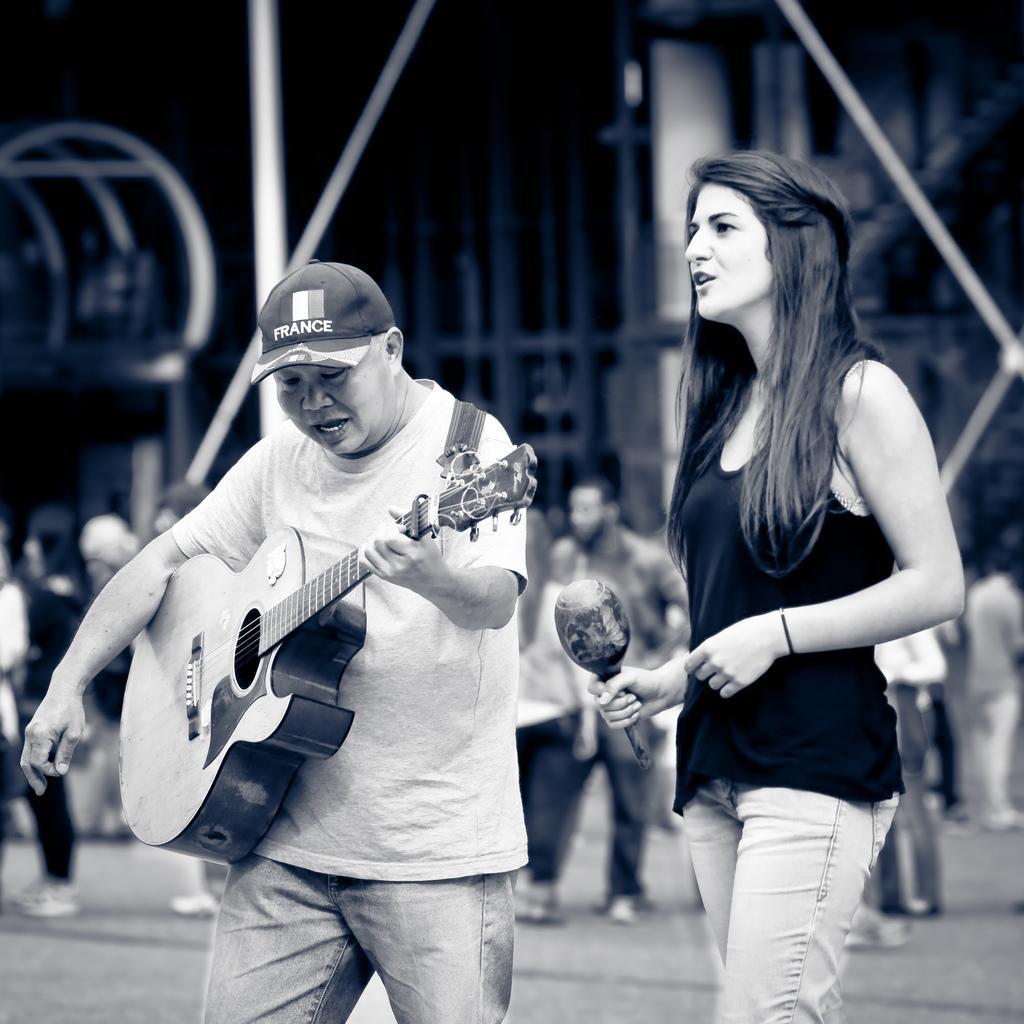How would you summarize this image in a sentence or two? In this image I can see two people. One person is holding guitar and another one is holding the mic. At the background there are group of people. 